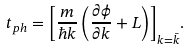Convert formula to latex. <formula><loc_0><loc_0><loc_500><loc_500>t _ { p h } = { \left [ \frac { m } { \hbar { k } } \left ( \frac { \partial \phi } { \partial k } + L \right ) \right ] } _ { k = \bar { k } } .</formula> 